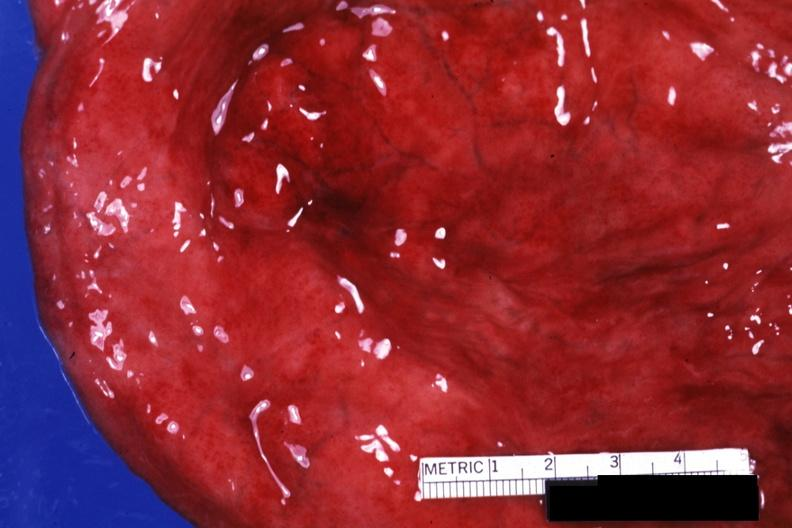s bladder present?
Answer the question using a single word or phrase. Yes 